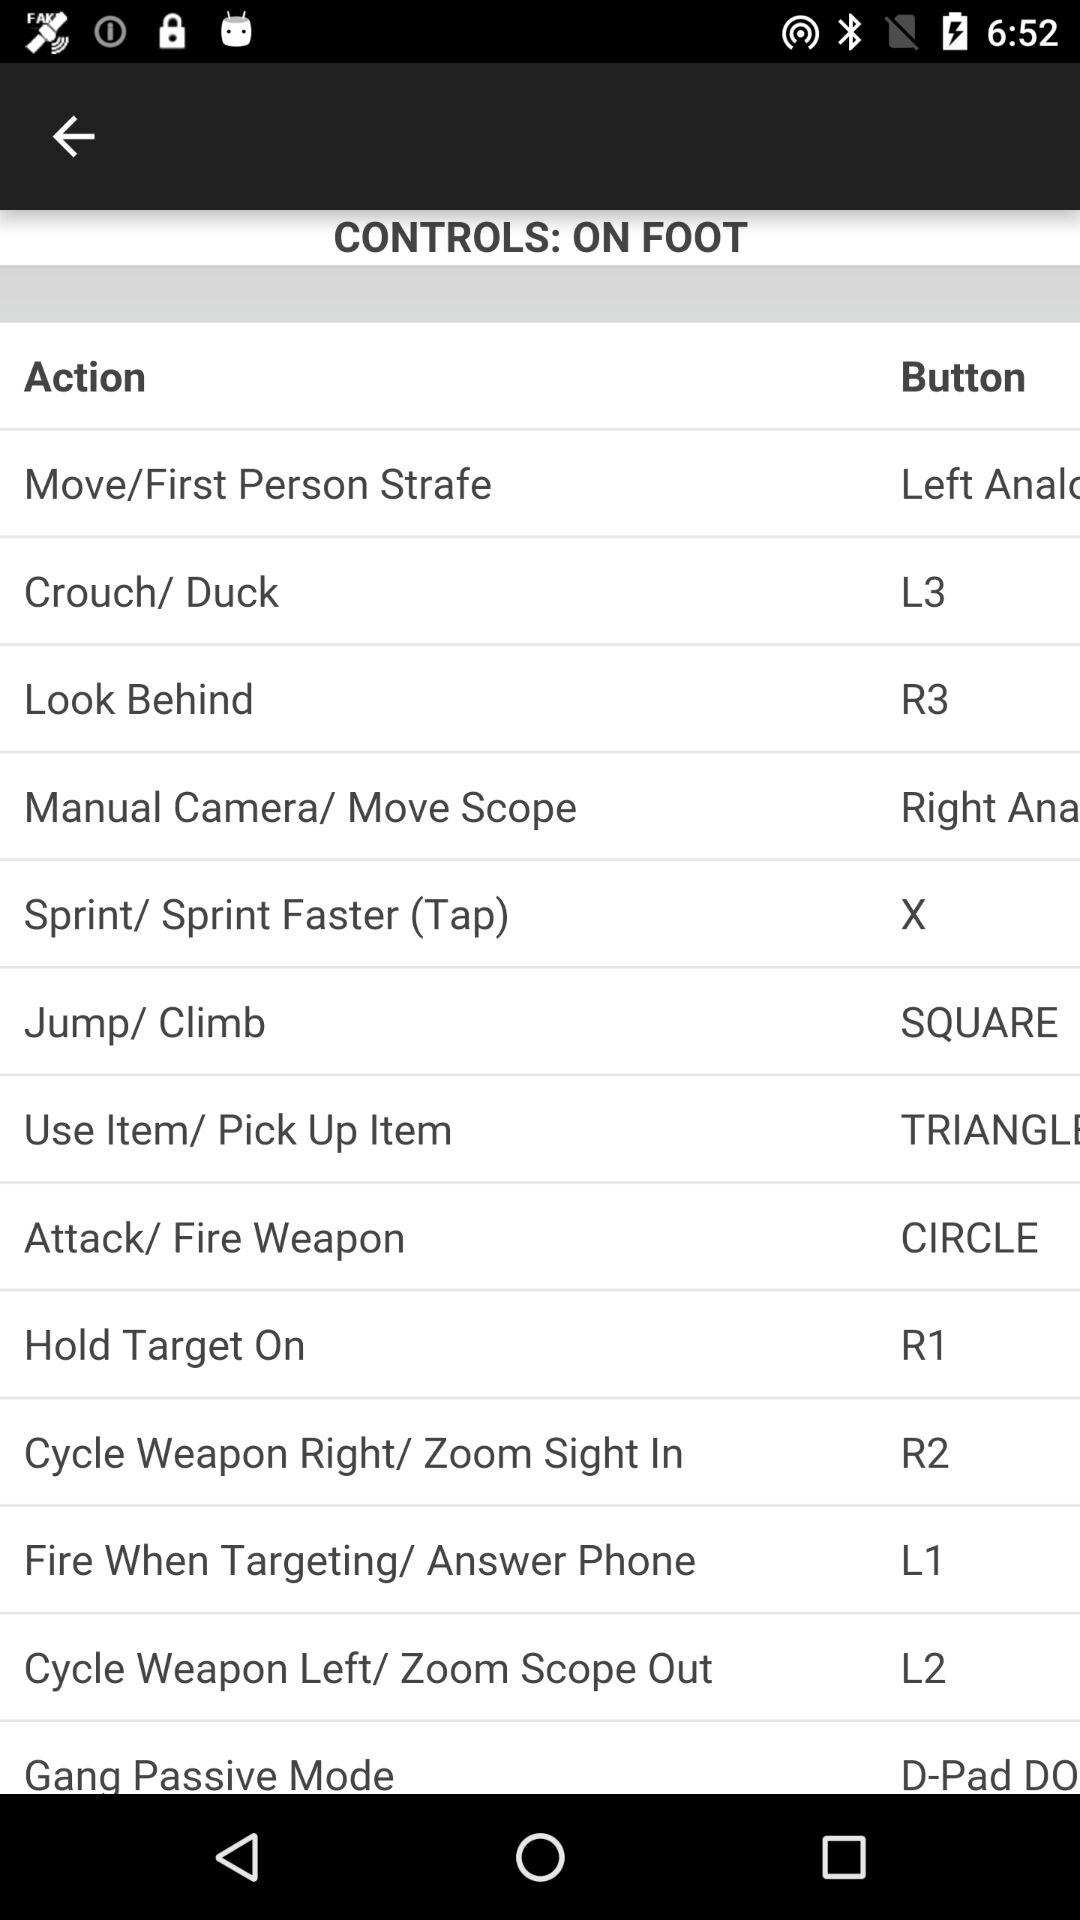What is the button for "Look Behind" action? The button is R3. 